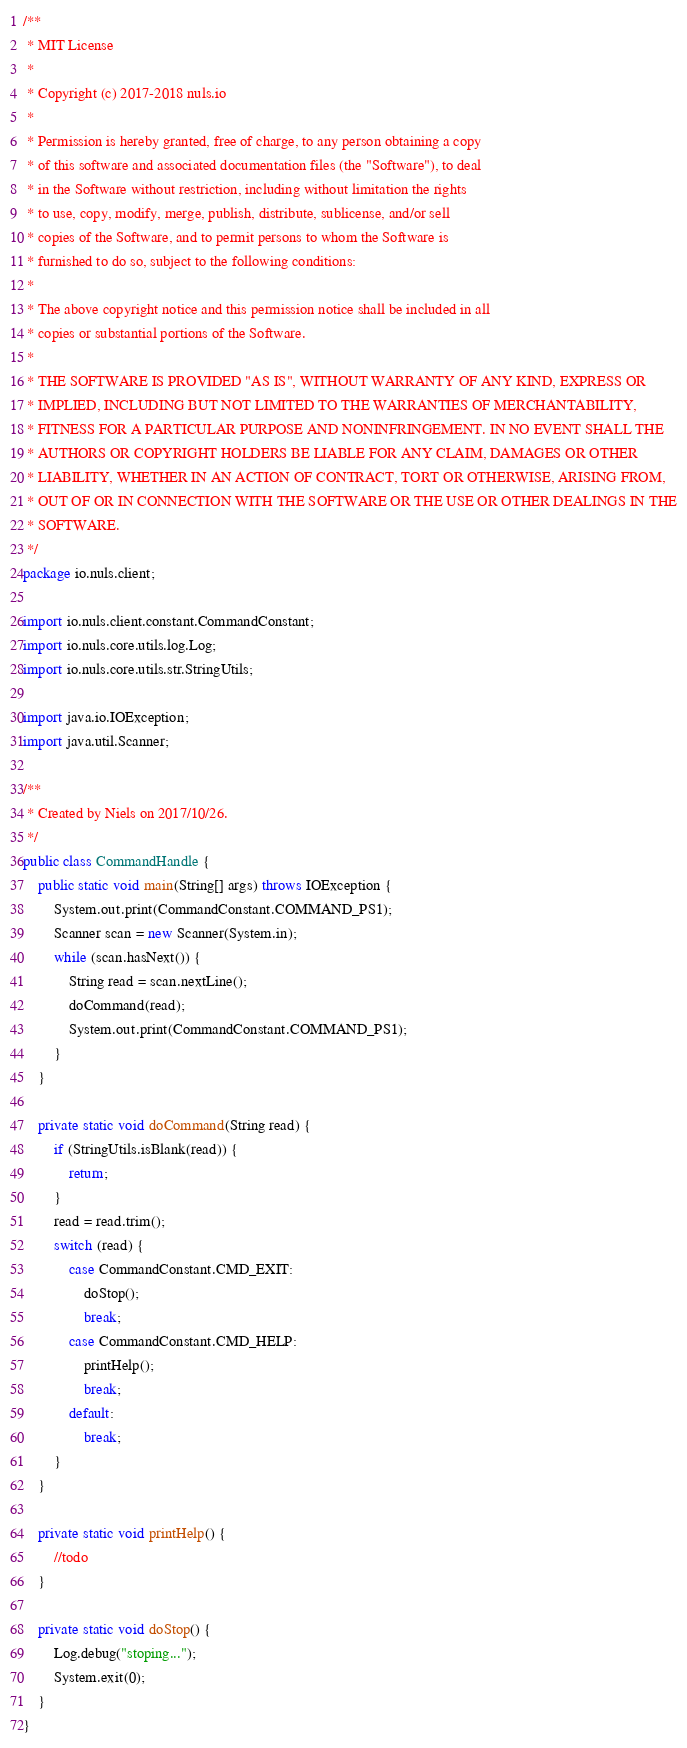<code> <loc_0><loc_0><loc_500><loc_500><_Java_>/**
 * MIT License
 *
 * Copyright (c) 2017-2018 nuls.io
 *
 * Permission is hereby granted, free of charge, to any person obtaining a copy
 * of this software and associated documentation files (the "Software"), to deal
 * in the Software without restriction, including without limitation the rights
 * to use, copy, modify, merge, publish, distribute, sublicense, and/or sell
 * copies of the Software, and to permit persons to whom the Software is
 * furnished to do so, subject to the following conditions:
 *
 * The above copyright notice and this permission notice shall be included in all
 * copies or substantial portions of the Software.
 *
 * THE SOFTWARE IS PROVIDED "AS IS", WITHOUT WARRANTY OF ANY KIND, EXPRESS OR
 * IMPLIED, INCLUDING BUT NOT LIMITED TO THE WARRANTIES OF MERCHANTABILITY,
 * FITNESS FOR A PARTICULAR PURPOSE AND NONINFRINGEMENT. IN NO EVENT SHALL THE
 * AUTHORS OR COPYRIGHT HOLDERS BE LIABLE FOR ANY CLAIM, DAMAGES OR OTHER
 * LIABILITY, WHETHER IN AN ACTION OF CONTRACT, TORT OR OTHERWISE, ARISING FROM,
 * OUT OF OR IN CONNECTION WITH THE SOFTWARE OR THE USE OR OTHER DEALINGS IN THE
 * SOFTWARE.
 */
package io.nuls.client;

import io.nuls.client.constant.CommandConstant;
import io.nuls.core.utils.log.Log;
import io.nuls.core.utils.str.StringUtils;

import java.io.IOException;
import java.util.Scanner;

/**
 * Created by Niels on 2017/10/26.
 */
public class CommandHandle {
    public static void main(String[] args) throws IOException {
        System.out.print(CommandConstant.COMMAND_PS1);
        Scanner scan = new Scanner(System.in);
        while (scan.hasNext()) {
            String read = scan.nextLine();
            doCommand(read);
            System.out.print(CommandConstant.COMMAND_PS1);
        }
    }

    private static void doCommand(String read) {
        if (StringUtils.isBlank(read)) {
            return;
        }
        read = read.trim();
        switch (read) {
            case CommandConstant.CMD_EXIT:
                doStop();
                break;
            case CommandConstant.CMD_HELP:
                printHelp();
                break;
            default:
                break;
        }
    }

    private static void printHelp() {
        //todo
    }

    private static void doStop() {
        Log.debug("stoping...");
        System.exit(0);
    }
}
</code> 